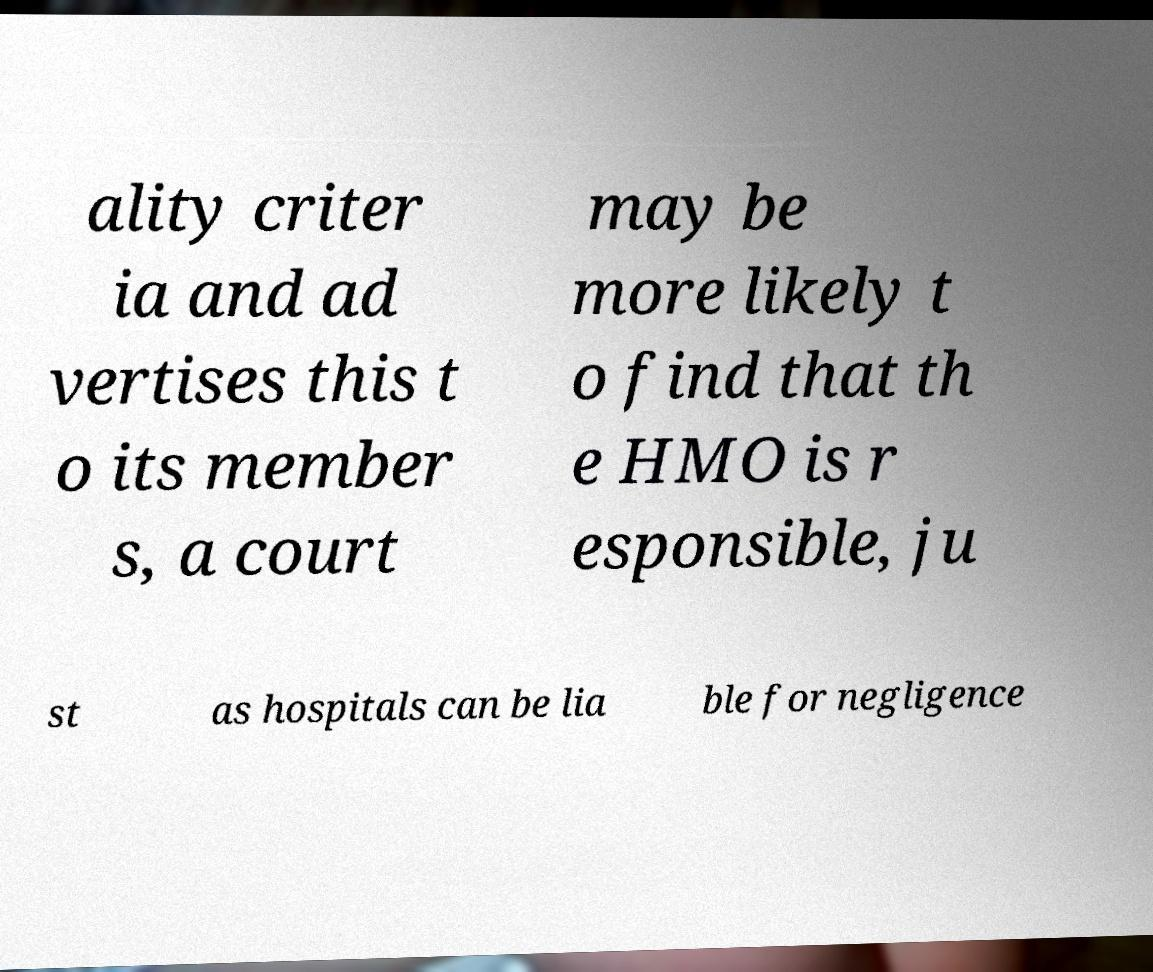Could you extract and type out the text from this image? ality criter ia and ad vertises this t o its member s, a court may be more likely t o find that th e HMO is r esponsible, ju st as hospitals can be lia ble for negligence 